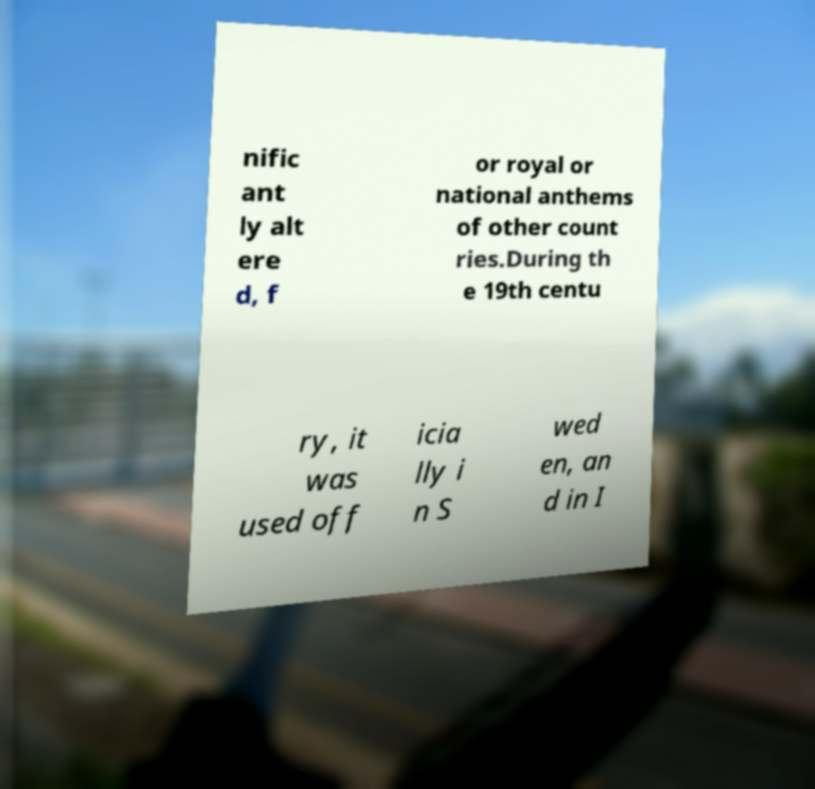Could you assist in decoding the text presented in this image and type it out clearly? nific ant ly alt ere d, f or royal or national anthems of other count ries.During th e 19th centu ry, it was used off icia lly i n S wed en, an d in I 